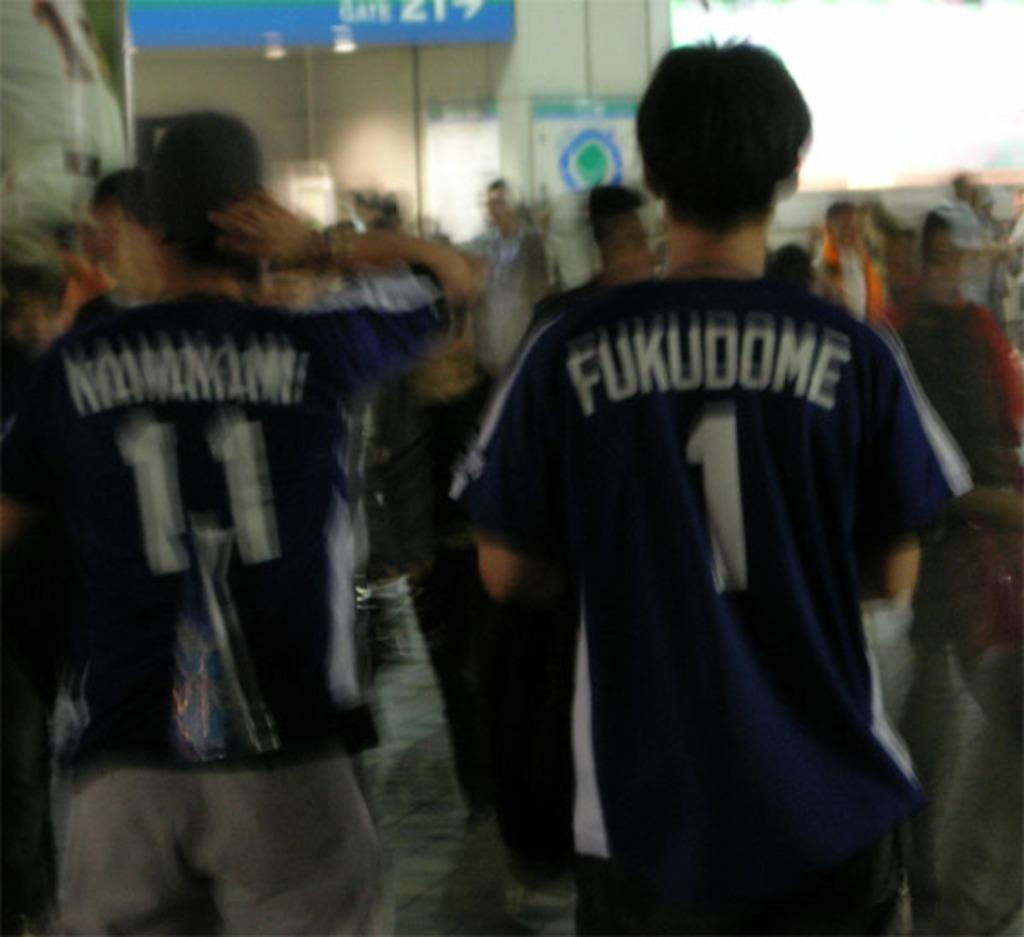<image>
Offer a succinct explanation of the picture presented. a jersey that has the word Fukudome on the back of their jersey 